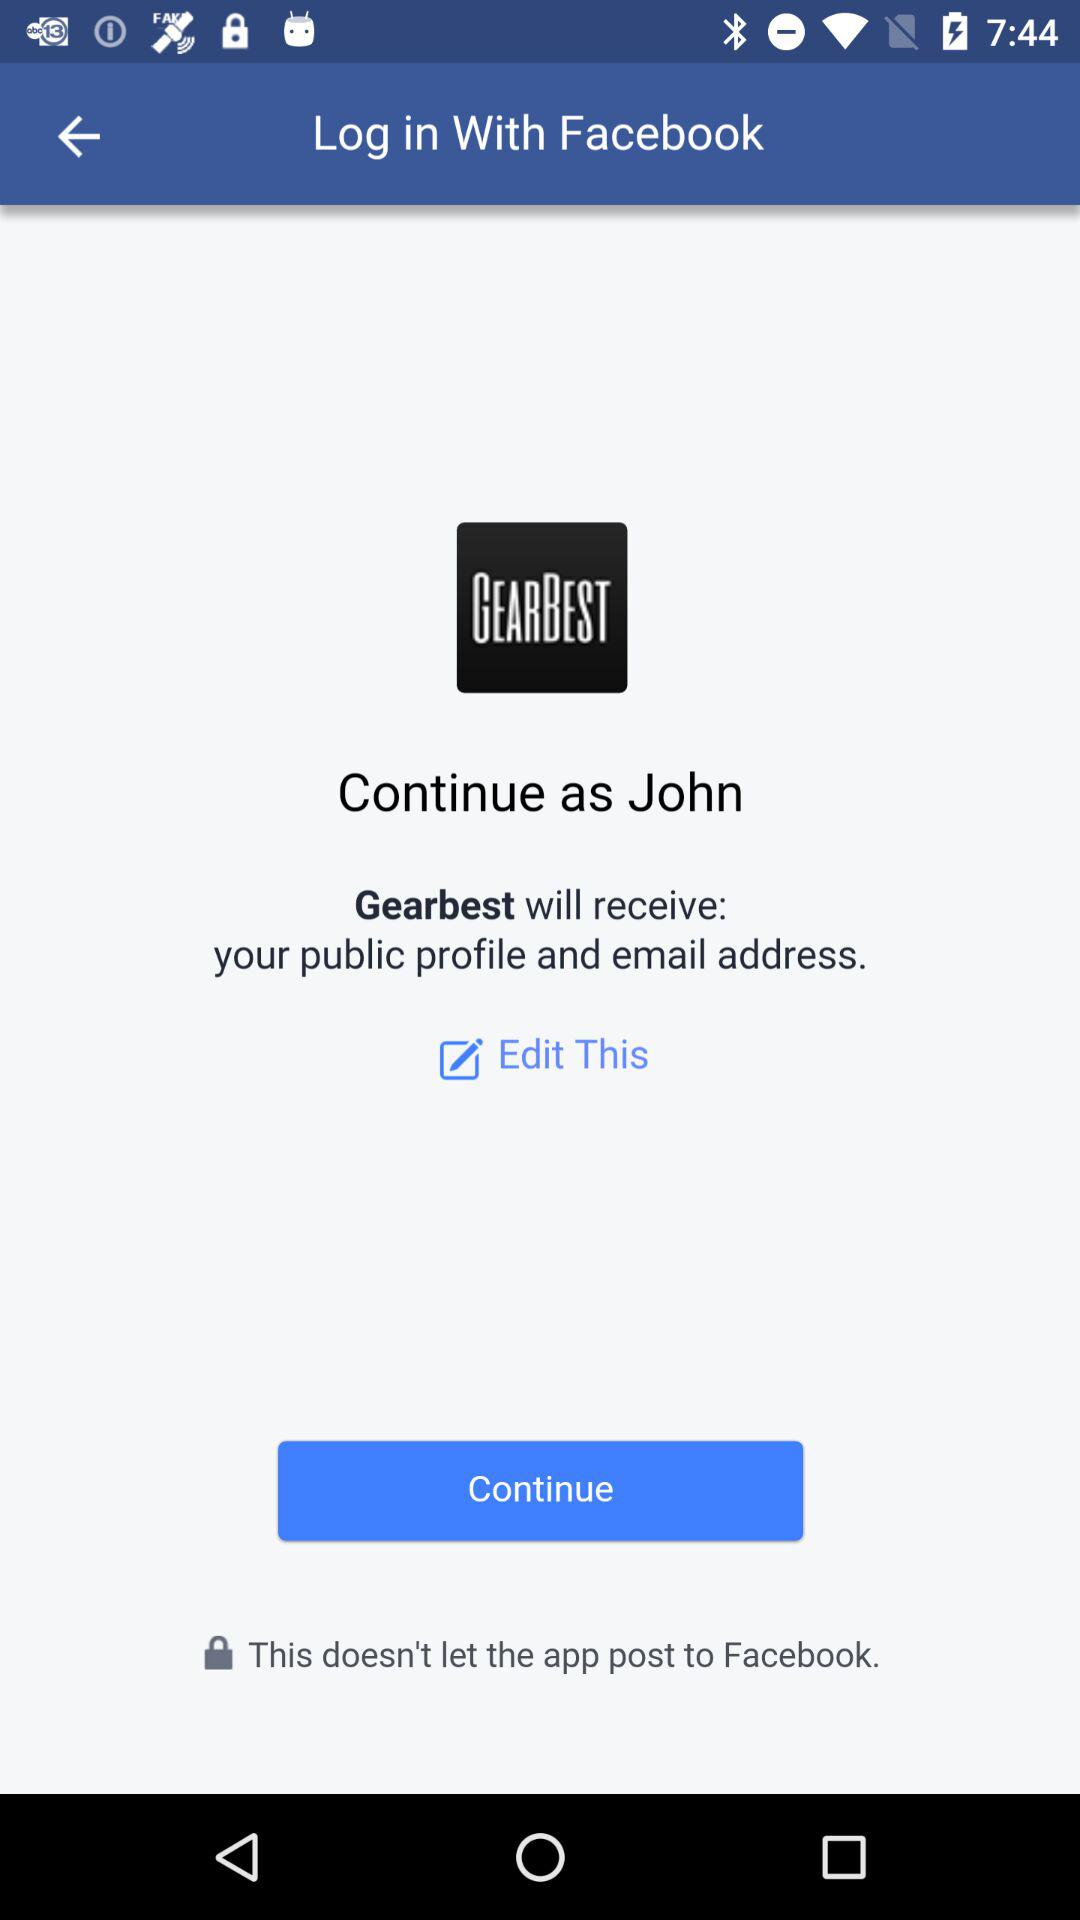What application is asking for permission? The application asking for permission is "Gearbest". 